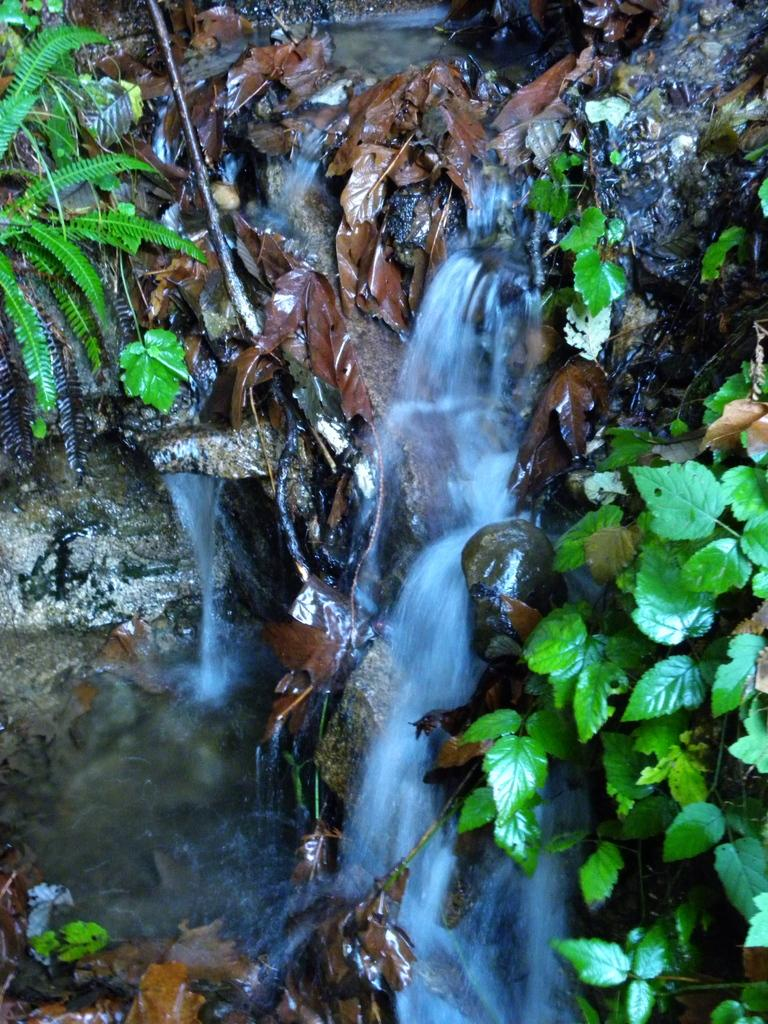Where was the image taken? The image was taken outdoors. What type of vegetation can be seen in the image? There are plants with green leaves in the image. What natural feature is present in the image? There is a waterfall in the image. What type of doctor can be seen examining the elbow in the image? There is no doctor or elbow present in the image; it features plants and a waterfall. 